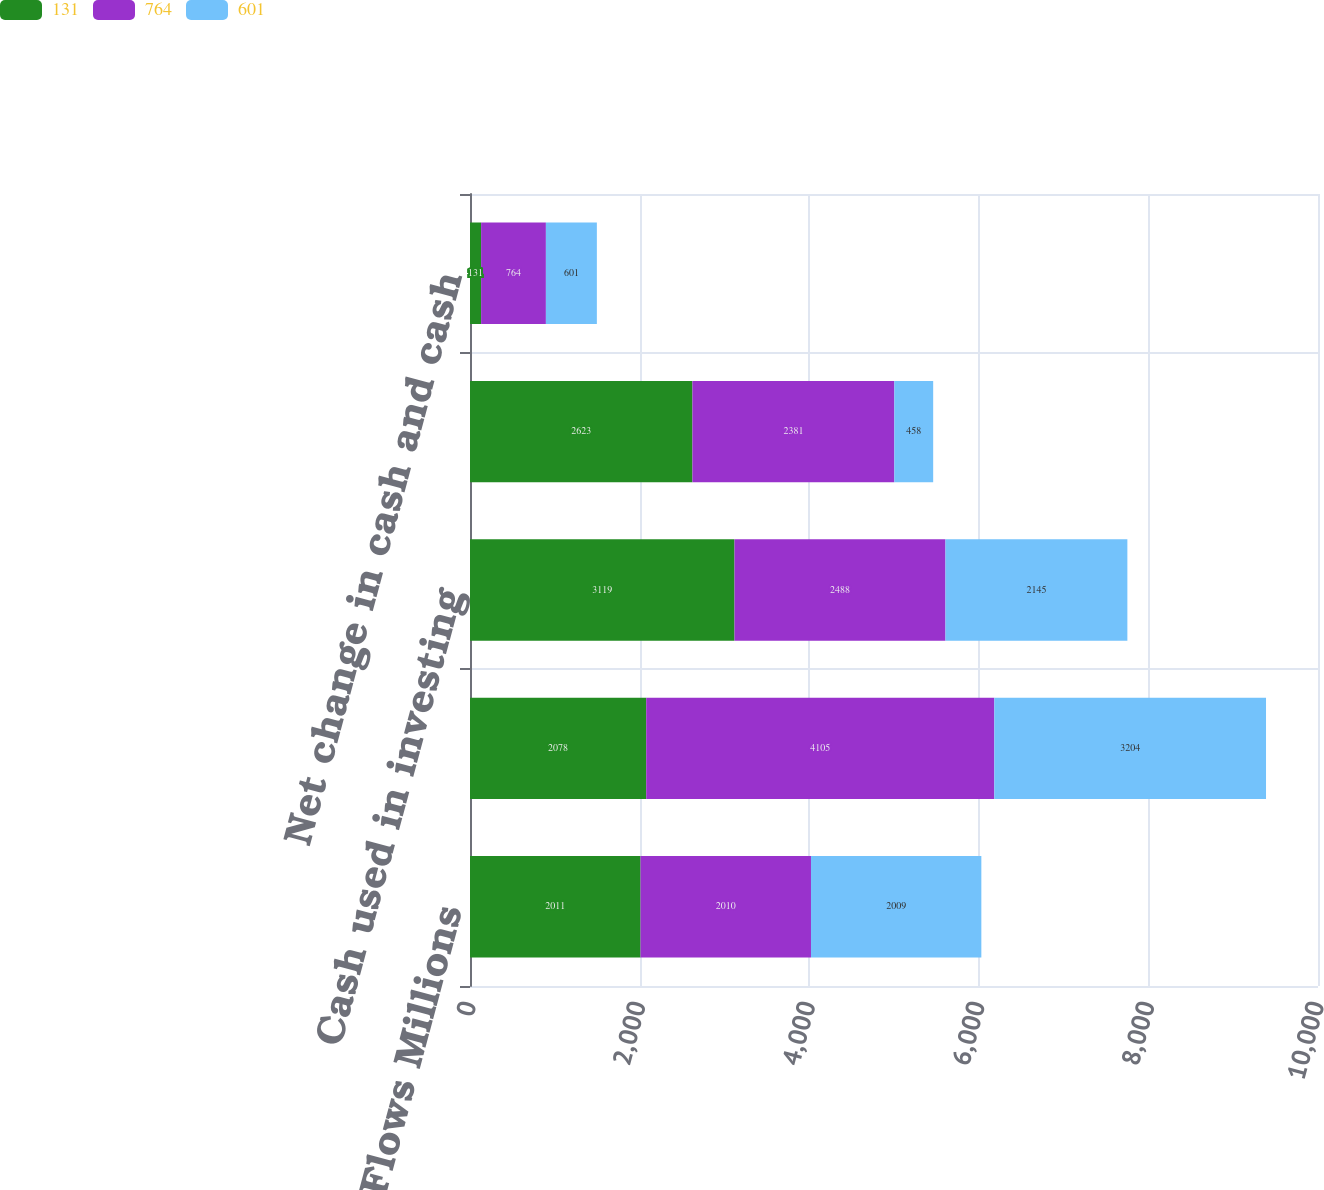<chart> <loc_0><loc_0><loc_500><loc_500><stacked_bar_chart><ecel><fcel>Cash Flows Millions<fcel>Cash provided by operating<fcel>Cash used in investing<fcel>Cash used in financing<fcel>Net change in cash and cash<nl><fcel>131<fcel>2011<fcel>2078<fcel>3119<fcel>2623<fcel>131<nl><fcel>764<fcel>2010<fcel>4105<fcel>2488<fcel>2381<fcel>764<nl><fcel>601<fcel>2009<fcel>3204<fcel>2145<fcel>458<fcel>601<nl></chart> 